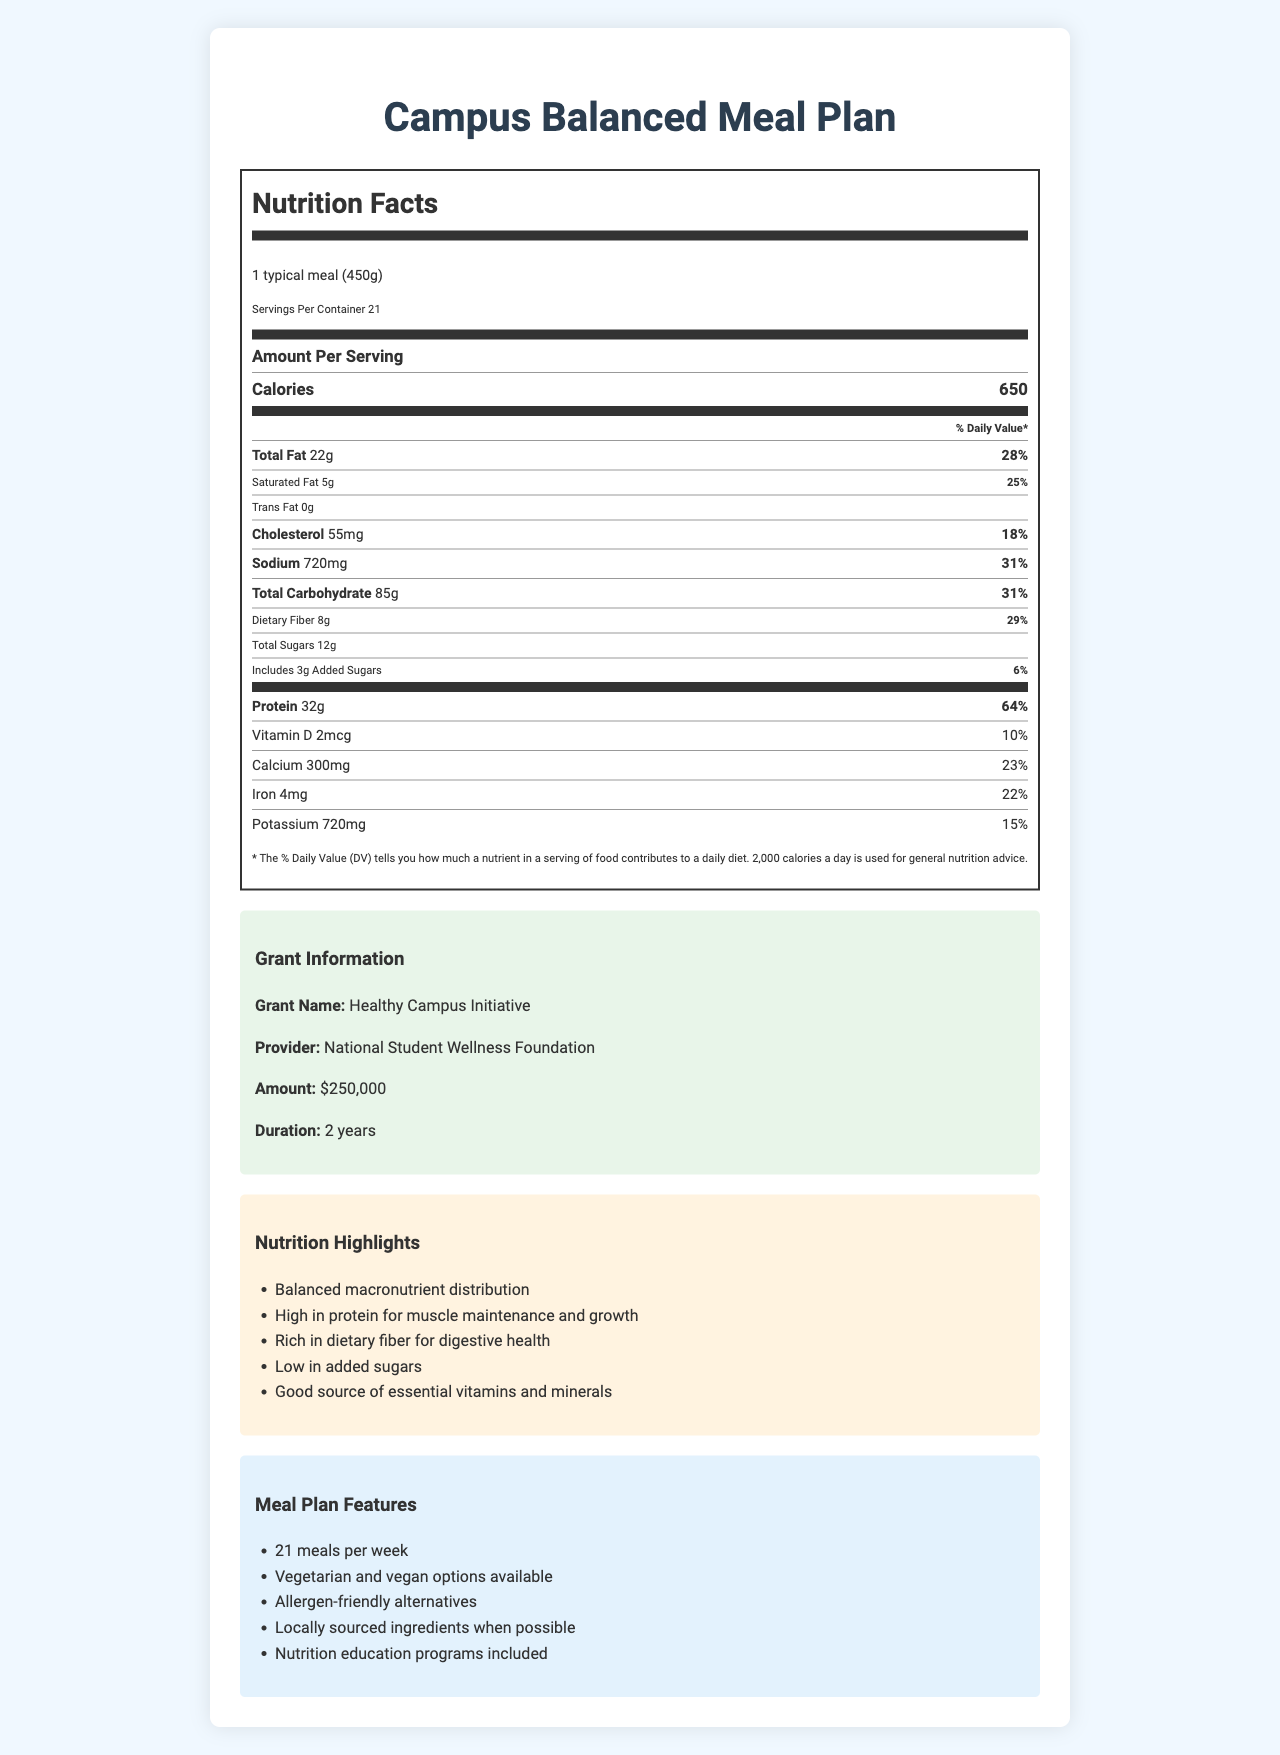What is the serving size for the Campus Balanced Meal Plan? The serving size is explicitly listed as "1 typical meal (450g)" under the Nutrition Facts section.
Answer: 1 typical meal (450g) What is the total fat content per serving, and what percentage of the Daily Value does it represent? The document shows that one serving contains 22g of total fat, which represents 28% of the Daily Value.
Answer: 22g, 28% How many servings are there in each container of the Campus Balanced Meal Plan? It states that there are 21 servings per container in the document.
Answer: 21 How much protein does one serving provide, and what is its percentage of the Daily Value? One serving provides 32g of protein, which is 64% of the Daily Value as specified in the Nutrition Facts.
Answer: 32g, 64% What is the sodium content per serving? The document lists the sodium content as 720mg per serving.
Answer: 720mg Which of the following is part of the meal plan's features? A. Fast food options B. Allergen-friendly alternatives C. Organic food only D. International cuisine It is stated in the document under “Meal Plan Features” that the plan includes allergen-friendly alternatives.
Answer: B. Allergen-friendly alternatives Which location offers meals as part of this plan? 1. Student Wellness Center 2. Main Dining Hall 3. Campus Gym 4. Library Café Main Dining Hall is listed as one of the campus dining locations where the meal plan is available.
Answer: 2. Main Dining Hall Is the Campus Balanced Meal Plan low in added sugars? The document highlights that the meal plan is low in added sugars under the Nutrition Highlights section.
Answer: Yes Summarize the main idea of the document. The document serves as a comprehensive guide to the nutritional information, features, and services associated with the Campus Balanced Meal Plan, highlighting the benefits and support provided by the grant.
Answer: The document outlines the nutritional content and features of the Campus Balanced Meal Plan, which is funded by a grant from the National Student Wellness Foundation. The plan provides balanced macronutrient distribution, high protein content, dietary fiber, low added sugars, and essential vitamins and minerals. It offers 21 meals per week with various options such as vegetarian, vegan, allergen-friendly alternatives, and locally sourced ingredients. The meal plan also includes nutrition education programs and consultation services at the Student Wellness Center. What is the percentage of the Daily Value for dietary fiber per serving? The Nutrition Facts section specifies that one serving provides 29% of the Daily Value for dietary fiber.
Answer: 29% Can you determine the exact sources of locally sourced ingredients mentioned in the meal plan? The document states that locally sourced ingredients are included "when possible," but it does not specify the exact sources or locations for these ingredients.
Answer: Cannot be determined How many calories does one serving of the Campus Balanced Meal Plan contain? The document lists the calorie content as 650 per serving.
Answer: 650 What is the grant amount provided by the National Student Wellness Foundation for the Healthy Campus Initiative? The document specifies that the grant amount is $250,000.
Answer: $250,000 Which of these nutrients is not explicitly listed in the Nutrition Facts? A. Calcium B. Vitamin C C. Iron D. Potassium The Nutrition Facts list calcium, iron, and potassium, but there is no mention of Vitamin C.
Answer: B. Vitamin C 